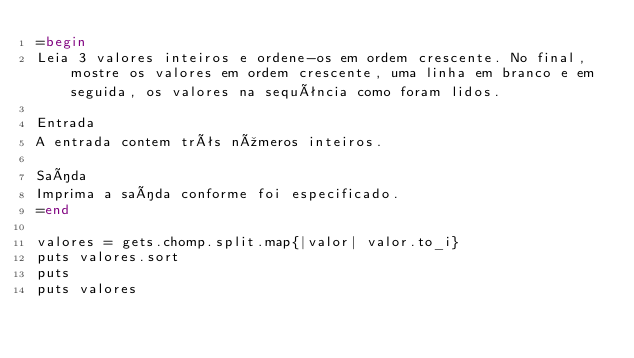Convert code to text. <code><loc_0><loc_0><loc_500><loc_500><_Ruby_>=begin
Leia 3 valores inteiros e ordene-os em ordem crescente. No final, mostre os valores em ordem crescente, uma linha em branco e em seguida, os valores na sequência como foram lidos.

Entrada
A entrada contem três números inteiros.

Saída
Imprima a saída conforme foi especificado.
=end

valores = gets.chomp.split.map{|valor| valor.to_i}
puts valores.sort
puts
puts valores</code> 